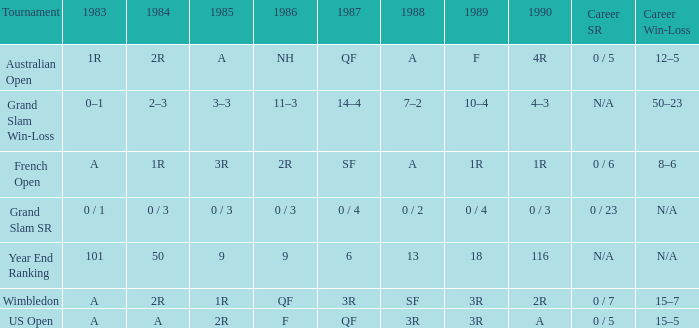In 1983 what is the tournament that is 0 / 1? Grand Slam SR. 